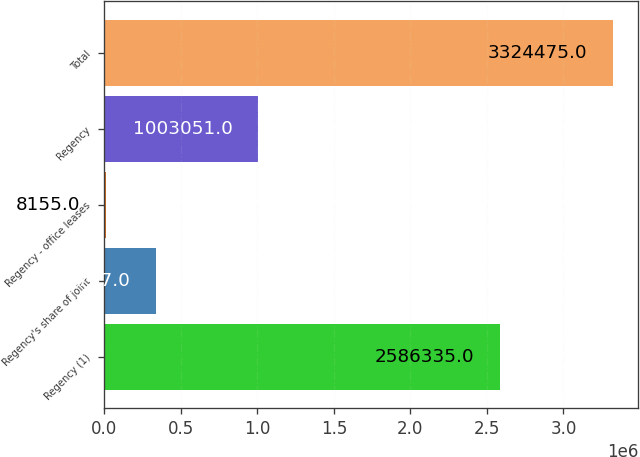Convert chart to OTSL. <chart><loc_0><loc_0><loc_500><loc_500><bar_chart><fcel>Regency (1)<fcel>Regency's share of joint<fcel>Regency - office leases<fcel>Regency<fcel>Total<nl><fcel>2.58634e+06<fcel>339787<fcel>8155<fcel>1.00305e+06<fcel>3.32448e+06<nl></chart> 